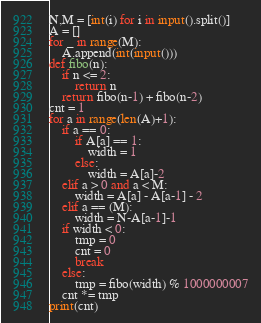<code> <loc_0><loc_0><loc_500><loc_500><_Python_>N,M = [int(i) for i in input().split()]
A = []
for _ in range(M):
    A.append(int(input()))
def fibo(n):
    if n <= 2:
        return n
    return fibo(n-1) + fibo(n-2)
cnt = 1
for a in range(len(A)+1):
    if a == 0:
        if A[a] == 1:
            width = 1
        else:
            width = A[a]-2
    elif a > 0 and a < M:
        width = A[a] - A[a-1] - 2
    elif a == (M):
        width = N-A[a-1]-1
    if width < 0:
        tmp = 0
        cnt = 0
        break
    else:
        tmp = fibo(width) % 1000000007
    cnt *= tmp
print(cnt)</code> 